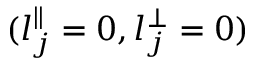<formula> <loc_0><loc_0><loc_500><loc_500>( l _ { j } ^ { \| } = 0 , l _ { j } ^ { \perp } = 0 )</formula> 